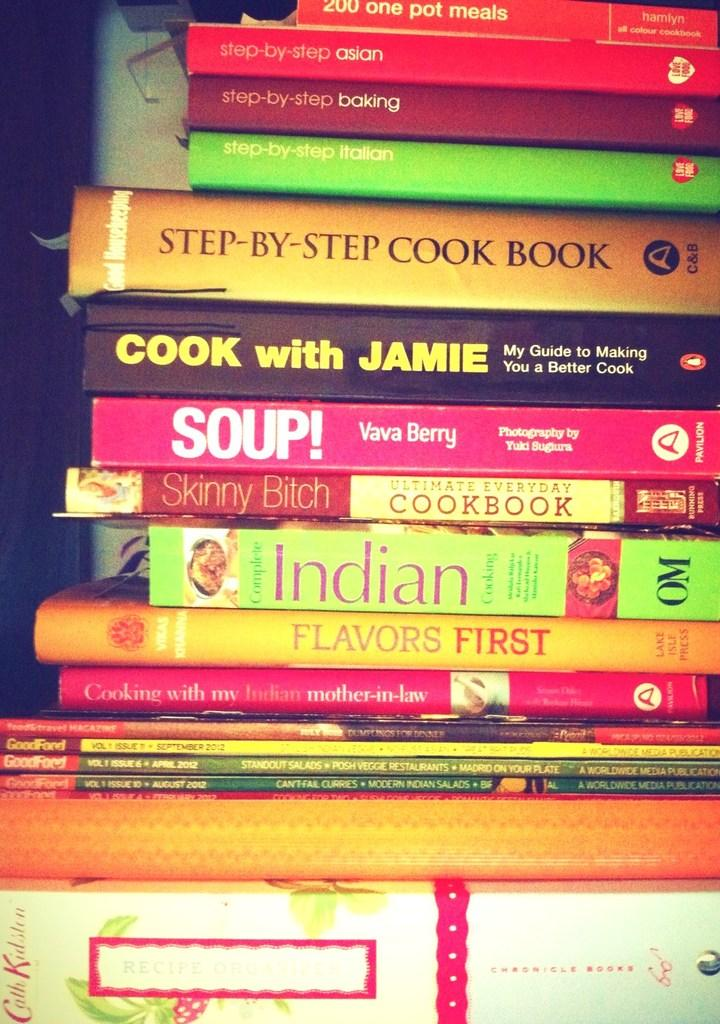<image>
Provide a brief description of the given image. A pile of books on cooking have titles like Flavors First, Cook with Jamie and Soup! 